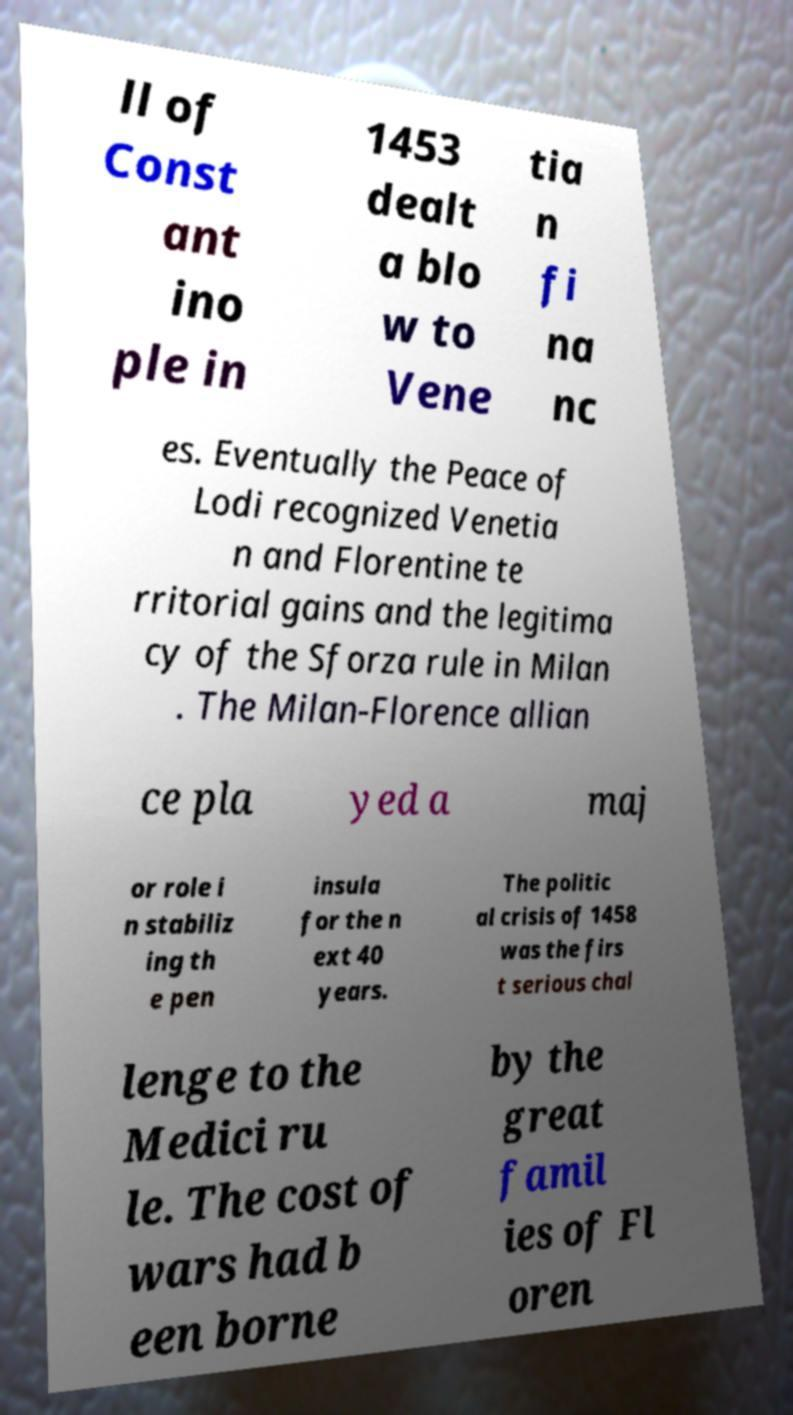Please read and relay the text visible in this image. What does it say? ll of Const ant ino ple in 1453 dealt a blo w to Vene tia n fi na nc es. Eventually the Peace of Lodi recognized Venetia n and Florentine te rritorial gains and the legitima cy of the Sforza rule in Milan . The Milan-Florence allian ce pla yed a maj or role i n stabiliz ing th e pen insula for the n ext 40 years. The politic al crisis of 1458 was the firs t serious chal lenge to the Medici ru le. The cost of wars had b een borne by the great famil ies of Fl oren 